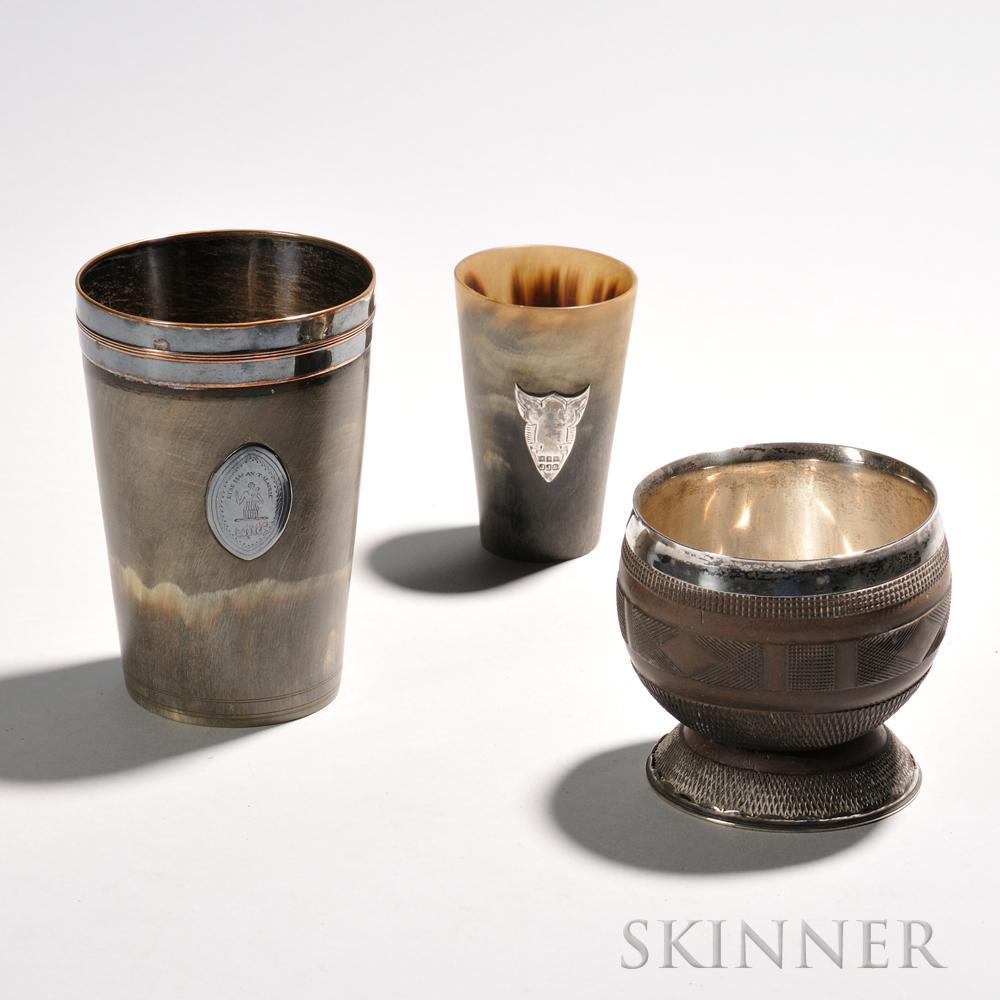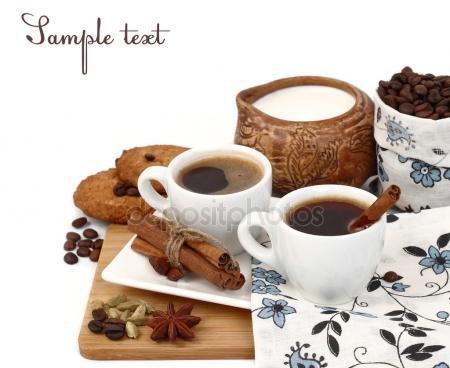The first image is the image on the left, the second image is the image on the right. Given the left and right images, does the statement "An image of a pair of filled mugs includes a small pile of loose coffee beans." hold true? Answer yes or no. Yes. The first image is the image on the left, the second image is the image on the right. Assess this claim about the two images: "There is a teapot with cups". Correct or not? Answer yes or no. No. 